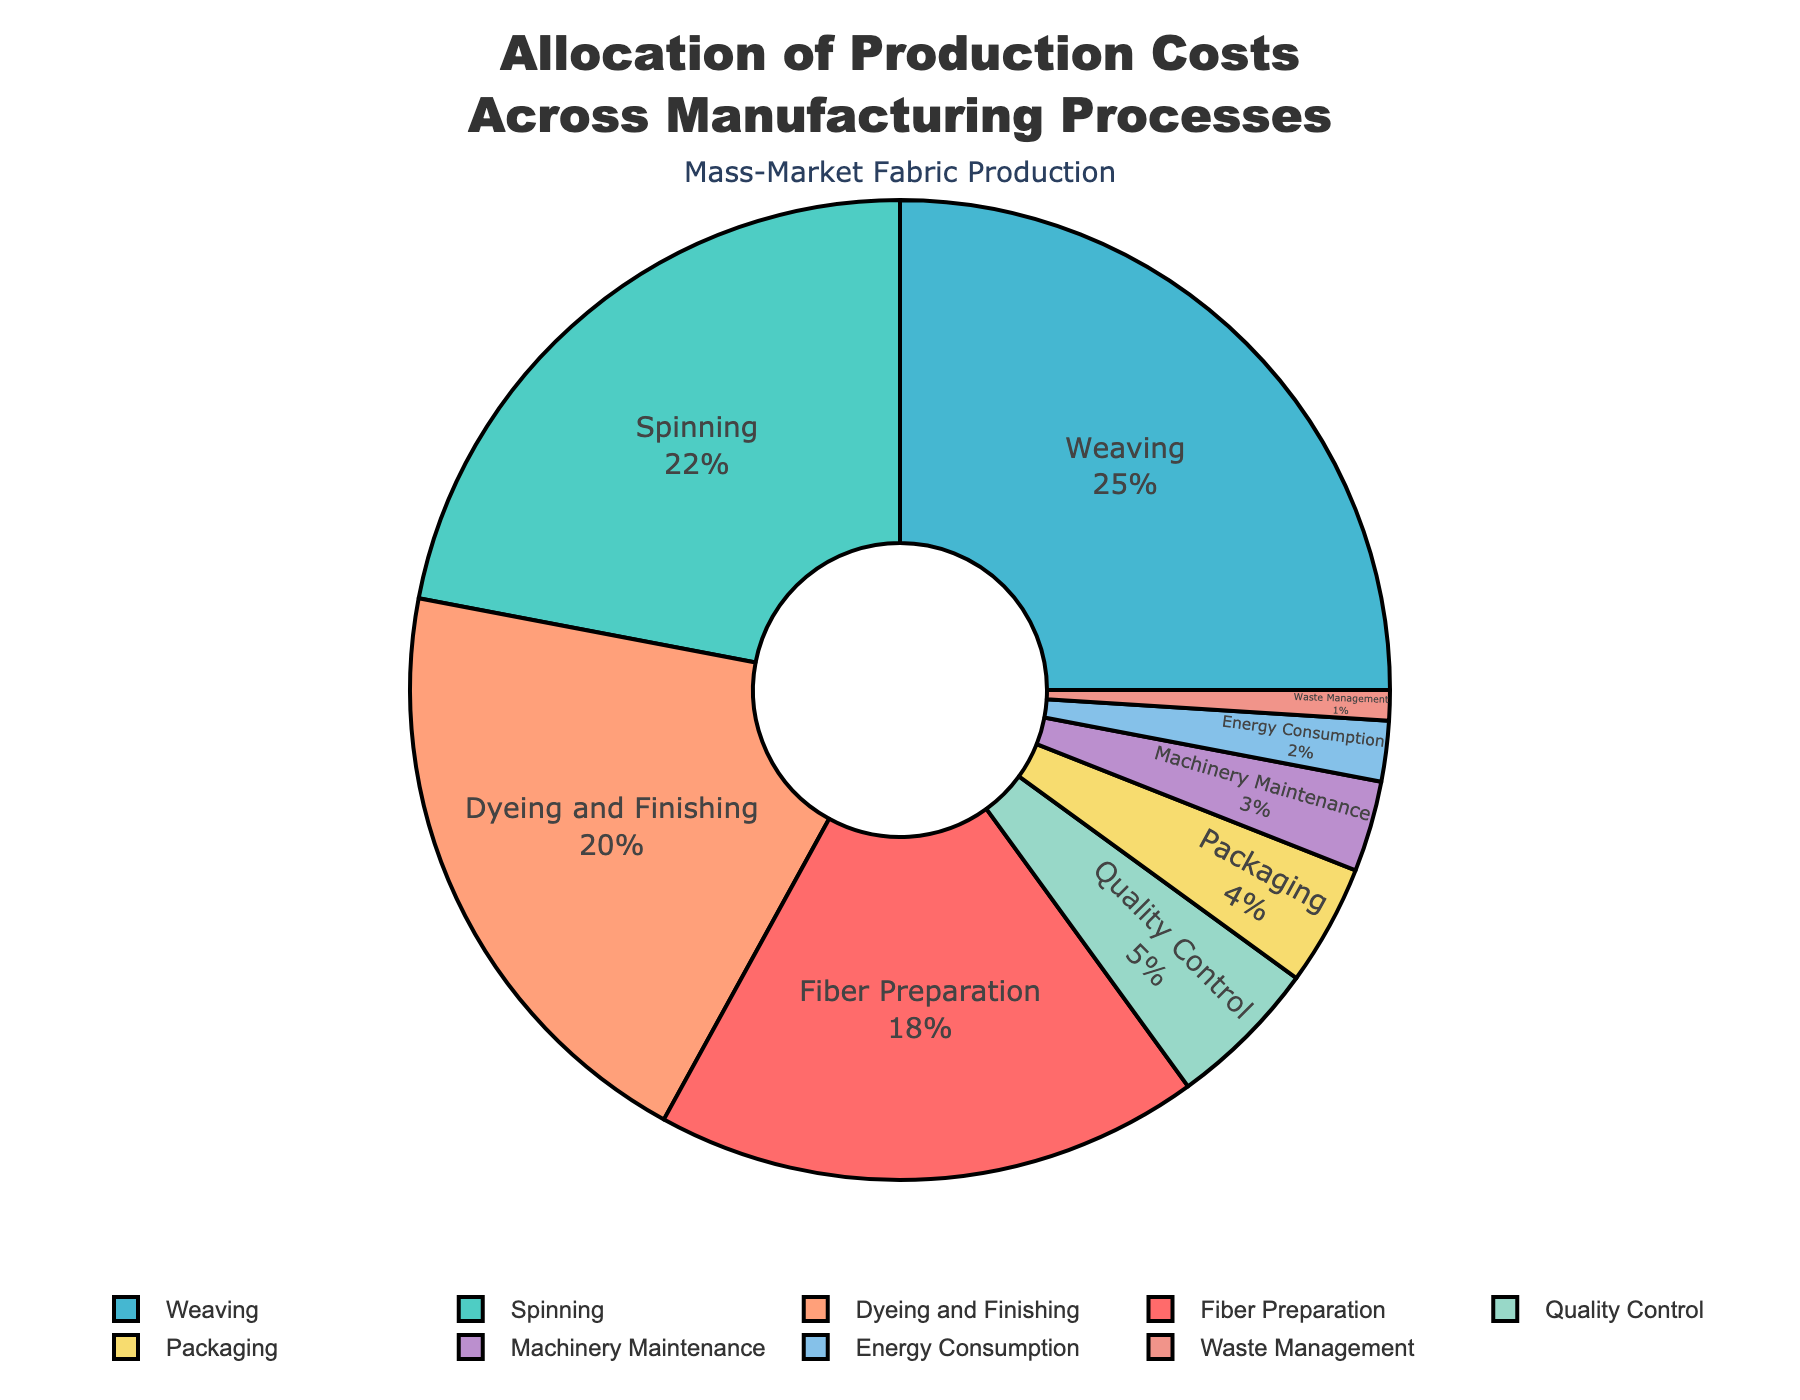Which manufacturing process has the highest cost percentage? By observing the pie chart, the process with the largest segment represents the highest cost percentage. The segment labeled "Weaving" appears to be the largest.
Answer: Weaving What is the combined percentage of cost for Dyeing and Finishing along with Spinning? According to the pie chart, Dyeing and Finishing is 20% and Spinning is 22%. Adding these two gives 20% + 22% = 42%.
Answer: 42% How does the cost percentage of Quality Control compare to that of Packaging? The pie chart shows the segment for Quality Control at 5% and for Packaging at 4%. 5% is greater than 4%.
Answer: Quality Control is greater Identify the processes that together contribute to less than 10% of the total costs. From the pie chart, the processes with low percentages are Machinery Maintenance (3%), Energy Consumption (2%), and Waste Management (1%). Adding these, 3% + 2% + 1% = 6%, which is less than 10%.
Answer: Machinery Maintenance, Energy Consumption, Waste Management Which process represents the smallest portion of production costs? The smallest segment on the pie chart corresponds to the process labeled "Waste Management" at 1%.
Answer: Waste Management By how much does the cost allocation for Weaving exceed that for Fiber Preparation? The pie chart shows Weaving at 25% and Fiber Preparation at 18%. Subtracting these, 25% - 18% = 7%.
Answer: 7% Calculate the total cost percentage allocated to Fiber Preparation, Quality Control, and Energy Consumption. From the pie chart, Fiber Preparation is 18%, Quality Control is 5%, and Energy Consumption is 2%. Adding these, 18% + 5% + 2% = 25%.
Answer: 25% Which processes together make up more than 50% of the total costs? From the pie chart, Spinning (22%) and Weaving (25%) together are 47%. Including Dyeing and Finishing (20%), the total is 22% + 25% + 20% = 67%, which is more than 50%.
Answer: Spinning, Weaving, Dyeing and Finishing 